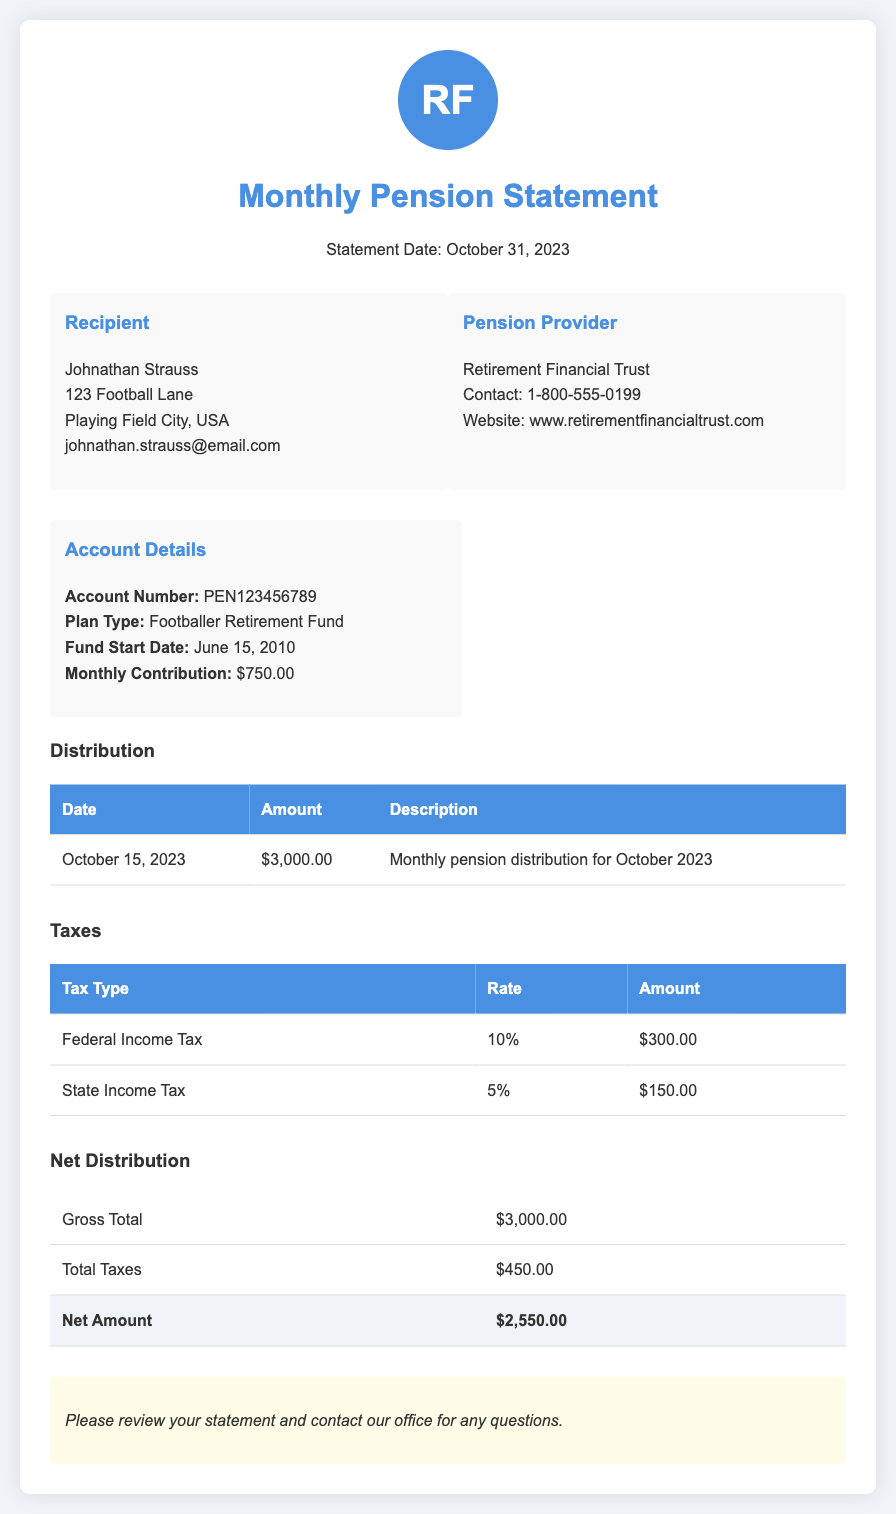What is the statement date? The statement date is explicitly mentioned in the document header, which is October 31, 2023.
Answer: October 31, 2023 Who is the pension provider? The document lists the pension provider as Retirement Financial Trust.
Answer: Retirement Financial Trust What is the account number? The document provides the account number under Account Details, which is PEN123456789.
Answer: PEN123456789 What was the amount distributed in October 2023? The distribution table shows that the amount distributed was $3,000.00 for October 2023.
Answer: $3,000.00 What is the total tax amount? The total tax amount is calculated from the individual tax types listed, which sum up to $450.00.
Answer: $450.00 What is the net amount received after taxes? The net distribution table shows the net amount after taxes is $2,550.00.
Answer: $2,550.00 What is the rate of state income tax? The document states the rate of state income tax as 5%.
Answer: 5% What is the description for the October distribution? The distribution is described as the monthly pension distribution for October 2023.
Answer: Monthly pension distribution for October 2023 What is the monthly contribution? The Account Details section specifies the monthly contribution amount as $750.00.
Answer: $750.00 